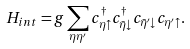<formula> <loc_0><loc_0><loc_500><loc_500>H _ { i n t } = g \sum _ { \eta \eta ^ { \prime } } c _ { \eta \uparrow } ^ { \dagger } c _ { \bar { \eta } \downarrow } ^ { \dagger } c _ { \bar { \eta } ^ { \prime } \downarrow } c _ { \eta ^ { \prime } \uparrow } .</formula> 